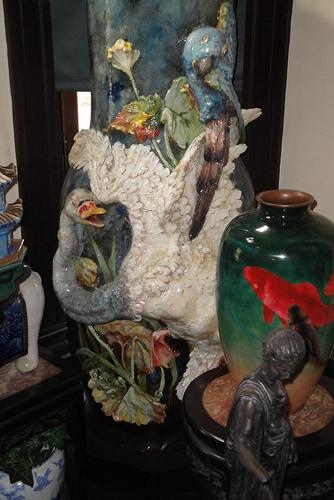What color is the vase?
Short answer required. Green. Are these objects used for cleaning?
Be succinct. No. What are these objects made of?
Be succinct. Ceramic. 